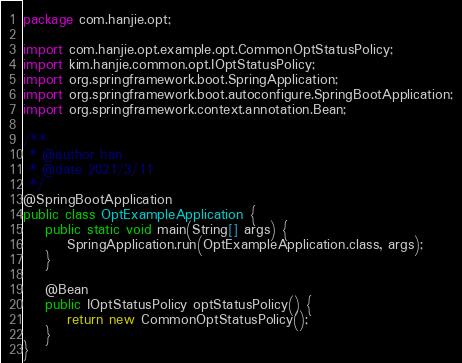<code> <loc_0><loc_0><loc_500><loc_500><_Java_>package com.hanjie.opt;

import com.hanjie.opt.example.opt.CommonOptStatusPolicy;
import kim.hanjie.common.opt.IOptStatusPolicy;
import org.springframework.boot.SpringApplication;
import org.springframework.boot.autoconfigure.SpringBootApplication;
import org.springframework.context.annotation.Bean;

/**
 * @author han
 * @date 2021/3/11
 */
@SpringBootApplication
public class OptExampleApplication {
    public static void main(String[] args) {
        SpringApplication.run(OptExampleApplication.class, args);
    }

    @Bean
    public IOptStatusPolicy optStatusPolicy() {
        return new CommonOptStatusPolicy();
    }
}
</code> 